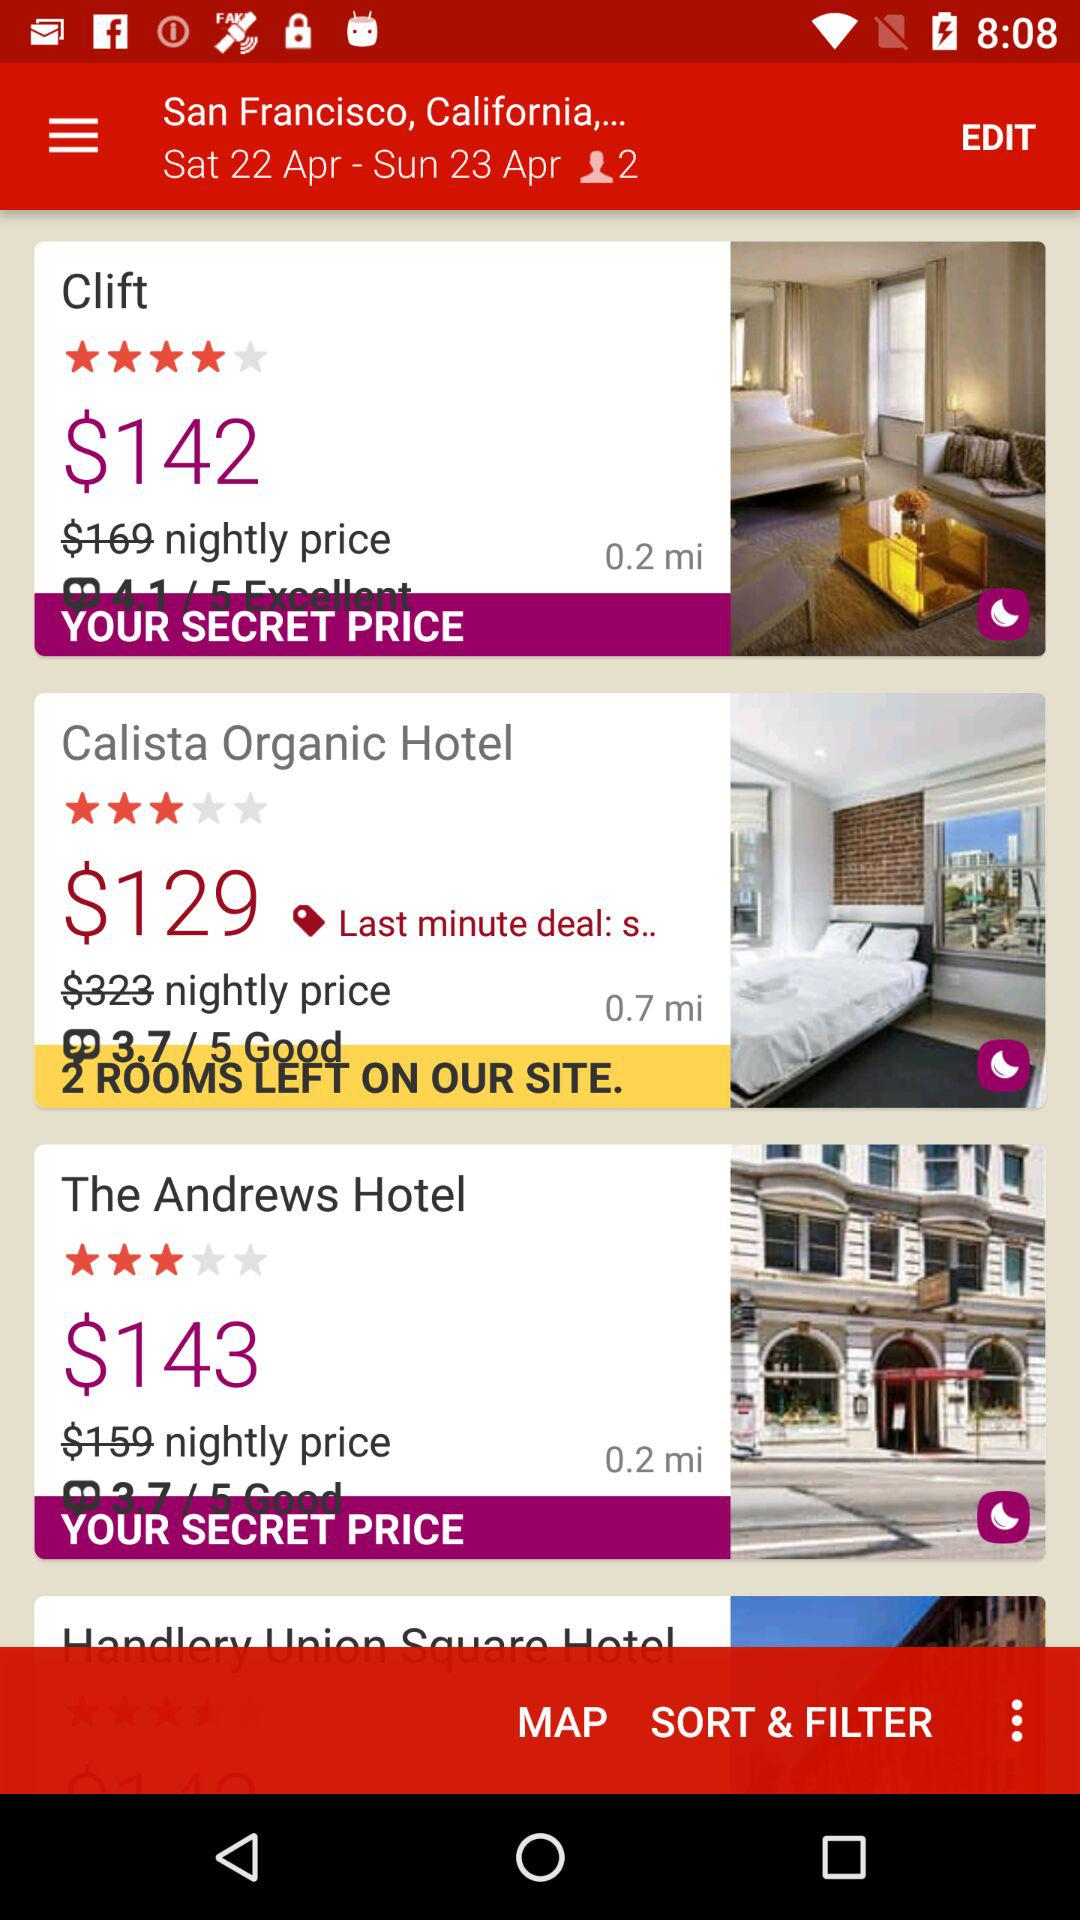What is the rating for "The Andrews Hotel"? The rating is 3.7. 